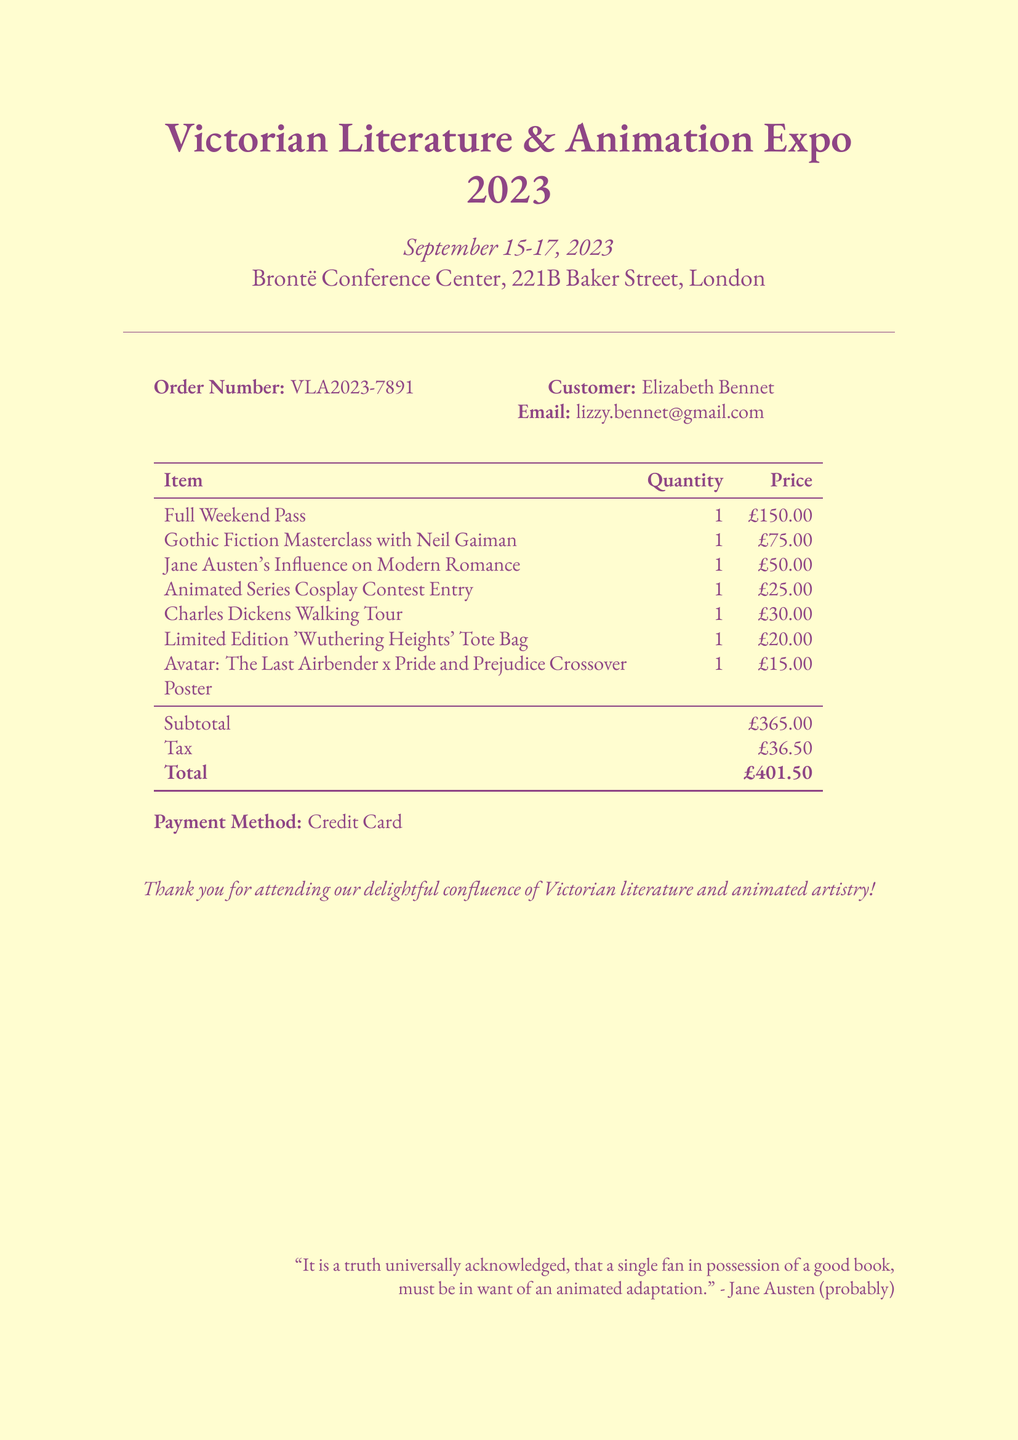What is the event name? The event name is clearly stated at the top of the document.
Answer: Victorian Literature & Animation Expo 2023 What is the venue address? The venue address is provided right below the event name and date.
Answer: 221B Baker Street, London How much is the Full Weekend Pass? The price of the Full Weekend Pass is listed in the ticket details section.
Answer: £150.00 What date is the Gothic Fiction Masterclass? The date of the Gothic Fiction Masterclass is indicated in the workshops section.
Answer: September 16, 2023 How many items were purchased in total? The total quantity can be derived from the ticket details, workshops, special events, and merchandise sections combined.
Answer: 7 What is the total amount payable including tax? The total amount includes the subtotal and tax, clearly provided in the document.
Answer: £401.50 Who is the customer? The customer's name is mentioned in the order details section of the document.
Answer: Elizabeth Bennet What payment method was used? The payment method is specifically stated at the bottom of the document.
Answer: Credit Card What is the name of the cosplay contest event? The name of the cosplay contest is listed in the special events section.
Answer: Animated Series Cosplay Contest Entry 